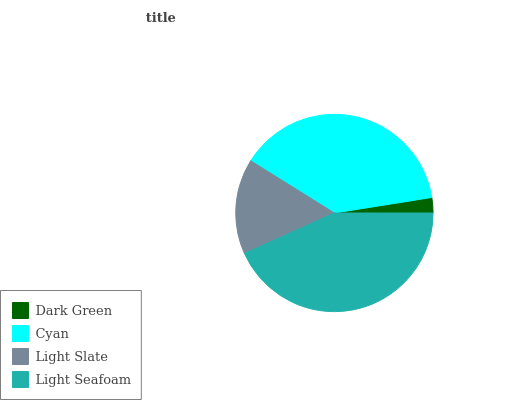Is Dark Green the minimum?
Answer yes or no. Yes. Is Light Seafoam the maximum?
Answer yes or no. Yes. Is Cyan the minimum?
Answer yes or no. No. Is Cyan the maximum?
Answer yes or no. No. Is Cyan greater than Dark Green?
Answer yes or no. Yes. Is Dark Green less than Cyan?
Answer yes or no. Yes. Is Dark Green greater than Cyan?
Answer yes or no. No. Is Cyan less than Dark Green?
Answer yes or no. No. Is Cyan the high median?
Answer yes or no. Yes. Is Light Slate the low median?
Answer yes or no. Yes. Is Light Seafoam the high median?
Answer yes or no. No. Is Cyan the low median?
Answer yes or no. No. 